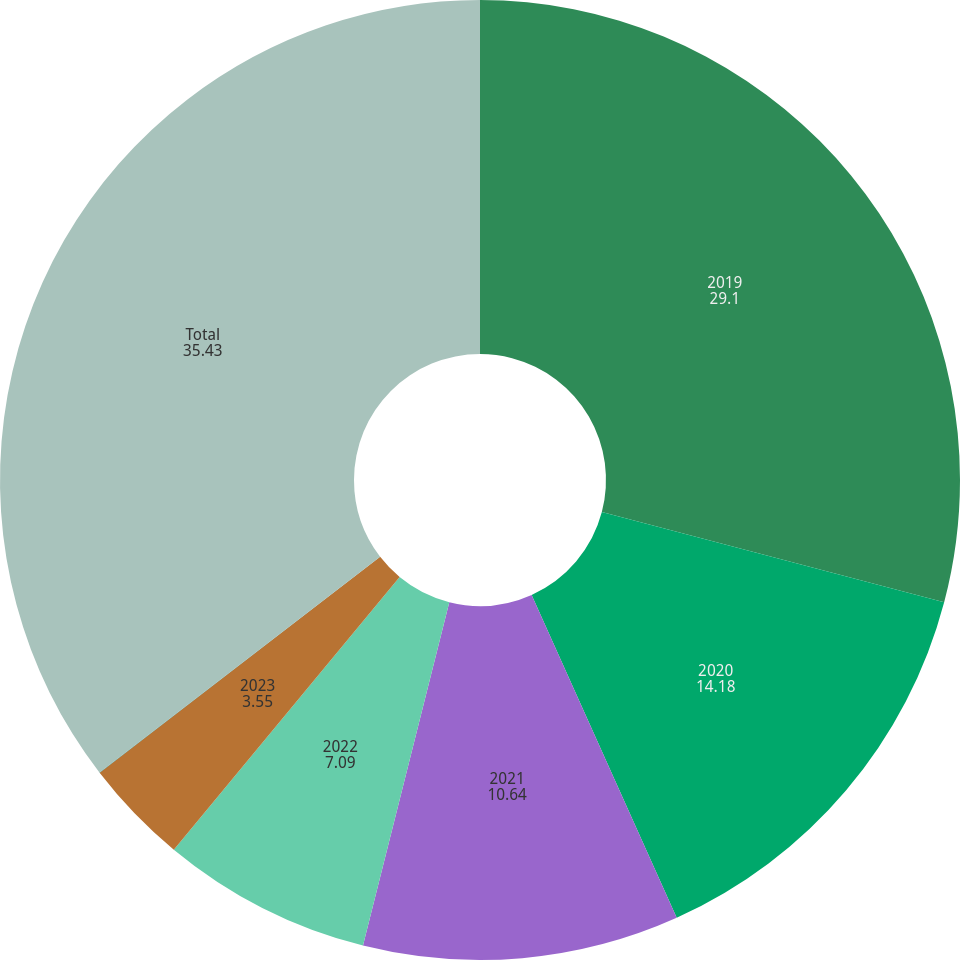Convert chart to OTSL. <chart><loc_0><loc_0><loc_500><loc_500><pie_chart><fcel>2019<fcel>2020<fcel>2021<fcel>2022<fcel>2023<fcel>2024 and thereafter<fcel>Total<nl><fcel>29.1%<fcel>14.18%<fcel>10.64%<fcel>7.09%<fcel>3.55%<fcel>0.01%<fcel>35.43%<nl></chart> 